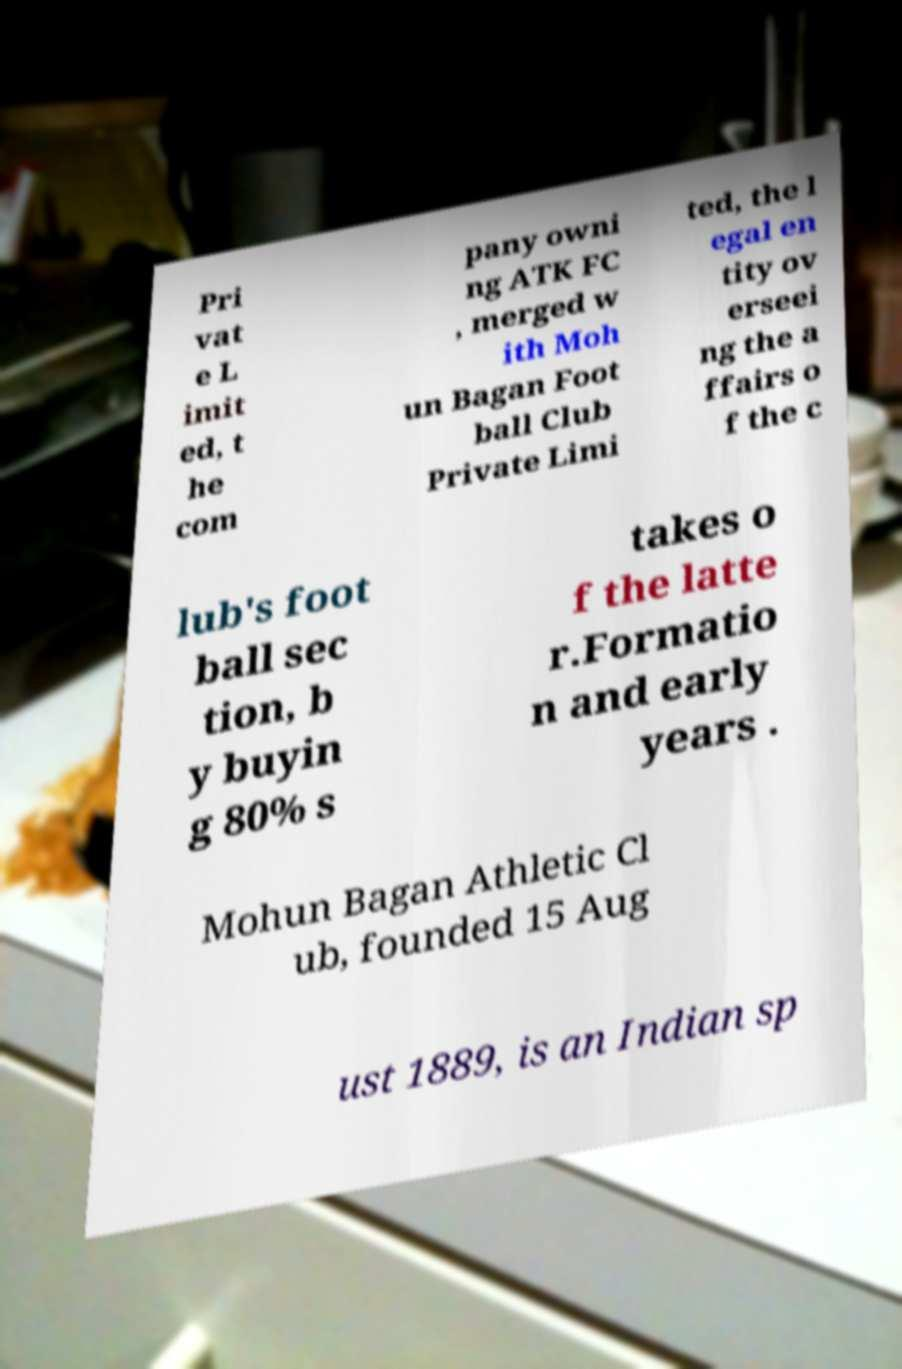Can you accurately transcribe the text from the provided image for me? Pri vat e L imit ed, t he com pany owni ng ATK FC , merged w ith Moh un Bagan Foot ball Club Private Limi ted, the l egal en tity ov erseei ng the a ffairs o f the c lub's foot ball sec tion, b y buyin g 80% s takes o f the latte r.Formatio n and early years . Mohun Bagan Athletic Cl ub, founded 15 Aug ust 1889, is an Indian sp 